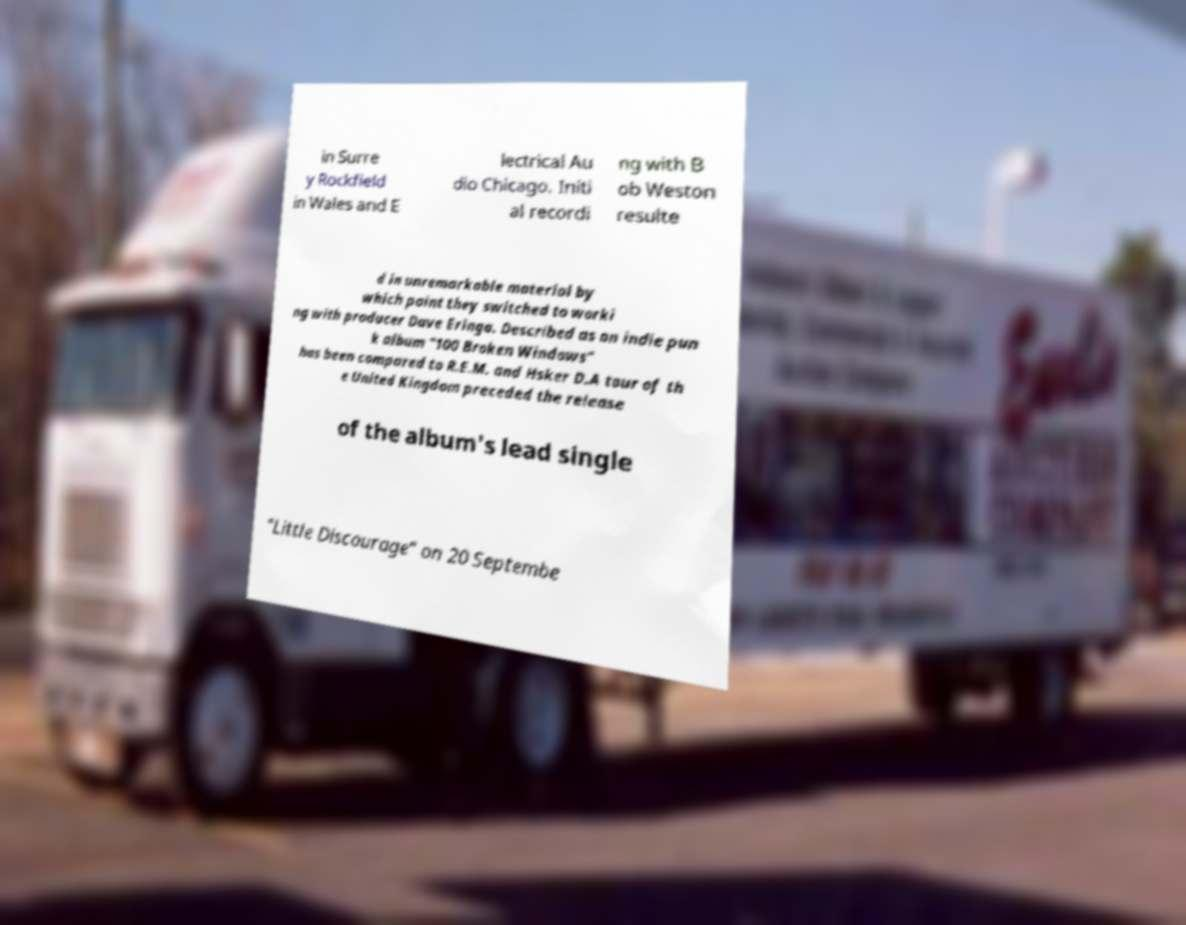There's text embedded in this image that I need extracted. Can you transcribe it verbatim? in Surre y Rockfield in Wales and E lectrical Au dio Chicago. Initi al recordi ng with B ob Weston resulte d in unremarkable material by which point they switched to worki ng with producer Dave Eringa. Described as an indie pun k album "100 Broken Windows" has been compared to R.E.M. and Hsker D.A tour of th e United Kingdom preceded the release of the album's lead single "Little Discourage" on 20 Septembe 